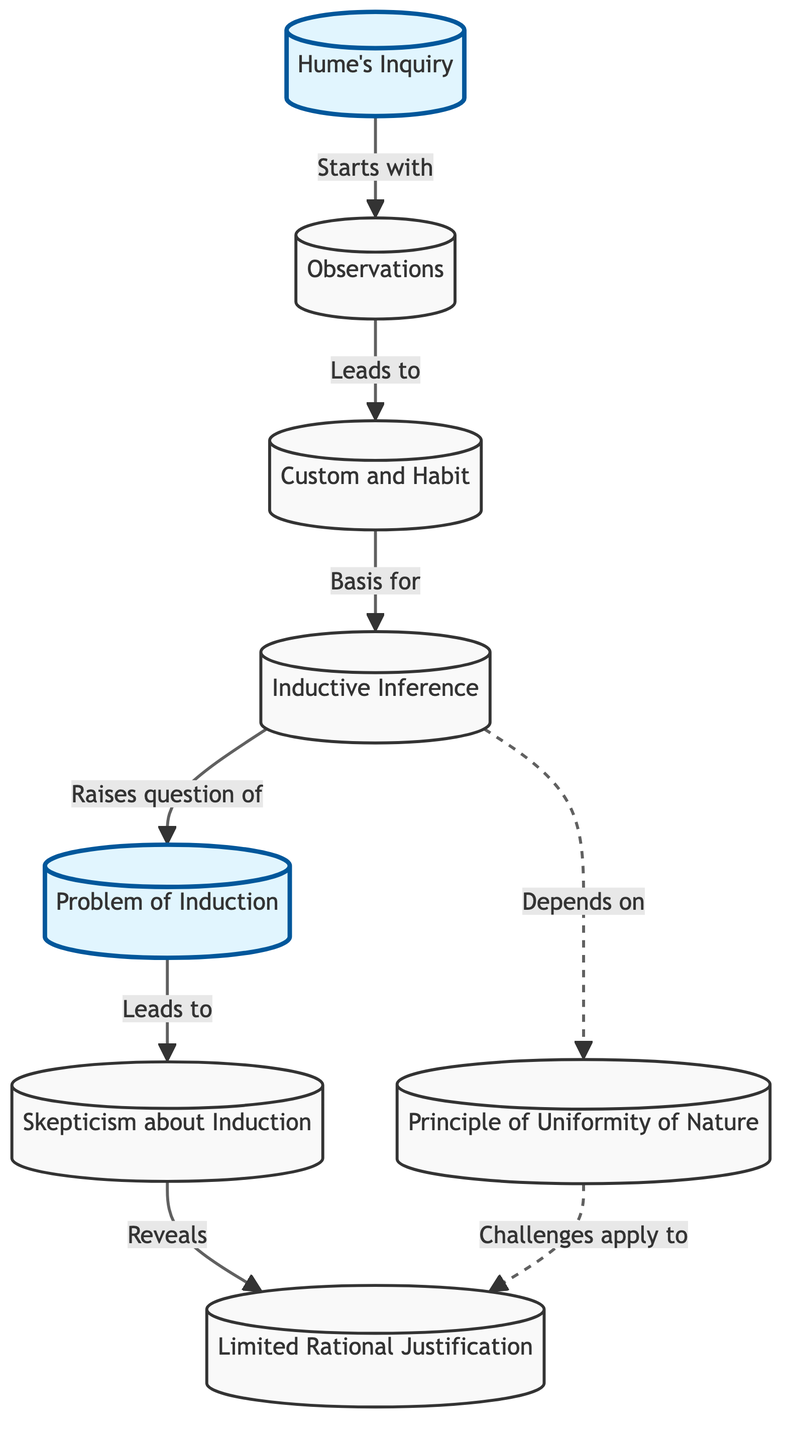What is the starting point of Hume's Inquiry? The diagram indicates that Hume's Inquiry begins with the node labeled "Hume's Inquiry," directly connecting to the node "Observations."
Answer: Observations How many nodes are in the diagram? By counting each node listed in the diagram, we find there are a total of eight nodes present.
Answer: 8 Which node raises the question of the Problem of Induction? The flow from "Inductive Inference" leads to the node labeled "Problem of Induction," indicating this connection raises that question.
Answer: Problem of Induction What does the node "Skepticism about Induction" reveal? The arrow leading from "Skepticism about Induction" points to "Limited Rational Justification," indicating that the skepticism reveals this limitation.
Answer: Limited Rational Justification How does "Inductive Inference" relate to the "Principle of Uniformity of Nature"? The dashed line from "Inductive Inference" to "Principle of Uniformity of Nature" shows that the inference depends on this principle, suggesting it's a fundamental aspect of inductive reasoning.
Answer: Depends on What connection can be drawn between the “Principle of Uniformity of Nature” and “Limited Rational Justification”? The diagram shows that the challenges that apply to the "Principle of Uniformity of Nature" also attribute to "Limited Rational Justification," as indicated by the dashed line.
Answer: Challenges apply to What is the nature of the connection from "Custom and Habit" to "Inductive Inference"? The flowchart indicates a direct relationship from "Custom and Habit" to "Inductive Inference," suggesting that customs and habitual actions are a basis for making inductive inferences.
Answer: Basis for What type of line connects "Inductive Inference" to "Principle of Uniformity of Nature"? The line connecting these nodes is represented as a dashed line, which typically indicates a dependency in the context of the diagram's logic.
Answer: Dashed line 